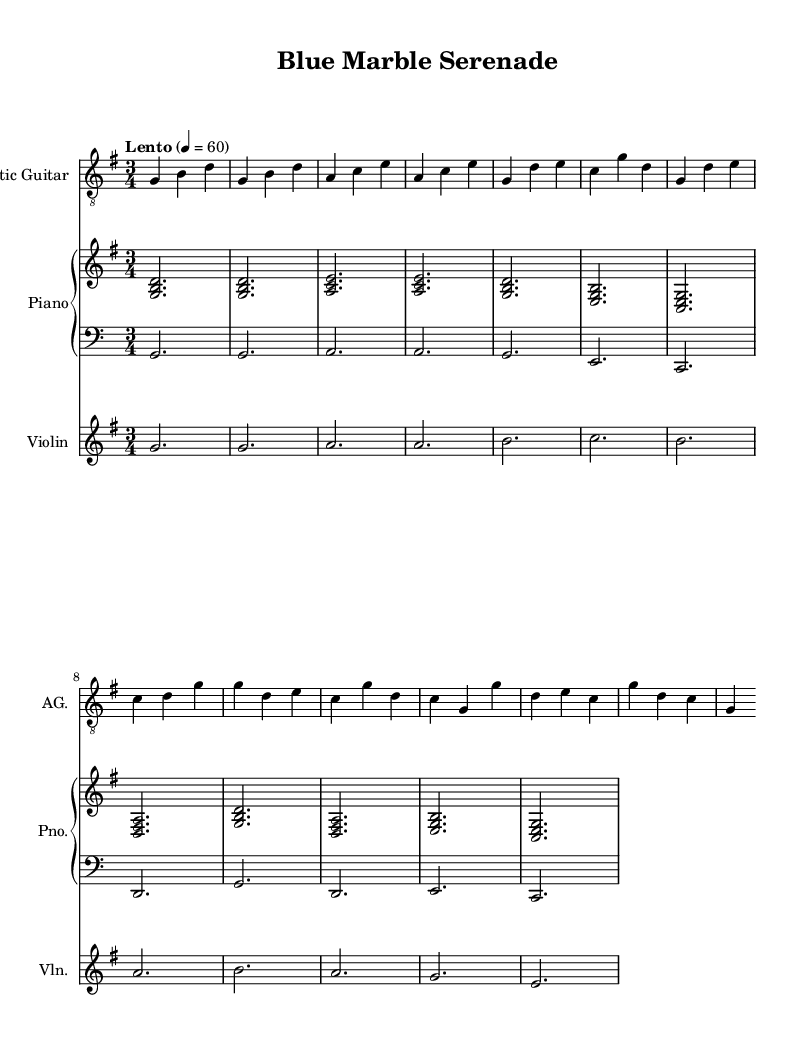What is the key signature of this music? The key signature is G major, which has one sharp (F#). This can be determined by looking at the key signature indicated at the beginning of the staff, showing one sharp.
Answer: G major What is the time signature of this music? The time signature is 3/4, meaning there are three beats per measure and the quarter note gets one beat. This is indicated at the beginning of the sheet music near the key signature.
Answer: 3/4 What is the tempo marking for this piece? The tempo marking is "Lento," which indicates a slow speed, typically around 40 to 60 beats per minute. This can be found near the top of the score accompanying a metronomic marking of 4 = 60.
Answer: Lento How many measures does the introduction contain? The introduction consists of 4 measures as we can count the measures from the introduction section shown in the sheet music. Each measure is separated by vertical lines, and counting gives a total of 4.
Answer: 4 What instruments are involved in this composition? The instruments involved are Acoustic Guitar, Piano, and Violin. This is identified at the beginning of each staff, where the instrument names are displayed.
Answer: Acoustic Guitar, Piano, Violin Which section follows the introduction in this piece? The section that follows the introduction is Verse 1. This can be inferred from the organization of the sheet music where the introduction is clearly delineated, and the next part is labeled as Verse 1.
Answer: Verse 1 How many voices are present in the chorus section? The chorus section features 3 voices: Acoustic Guitar, Piano, and Violin. Each instrument represents a voice, and they all come together in the chorus section to create harmonic texture.
Answer: 3 